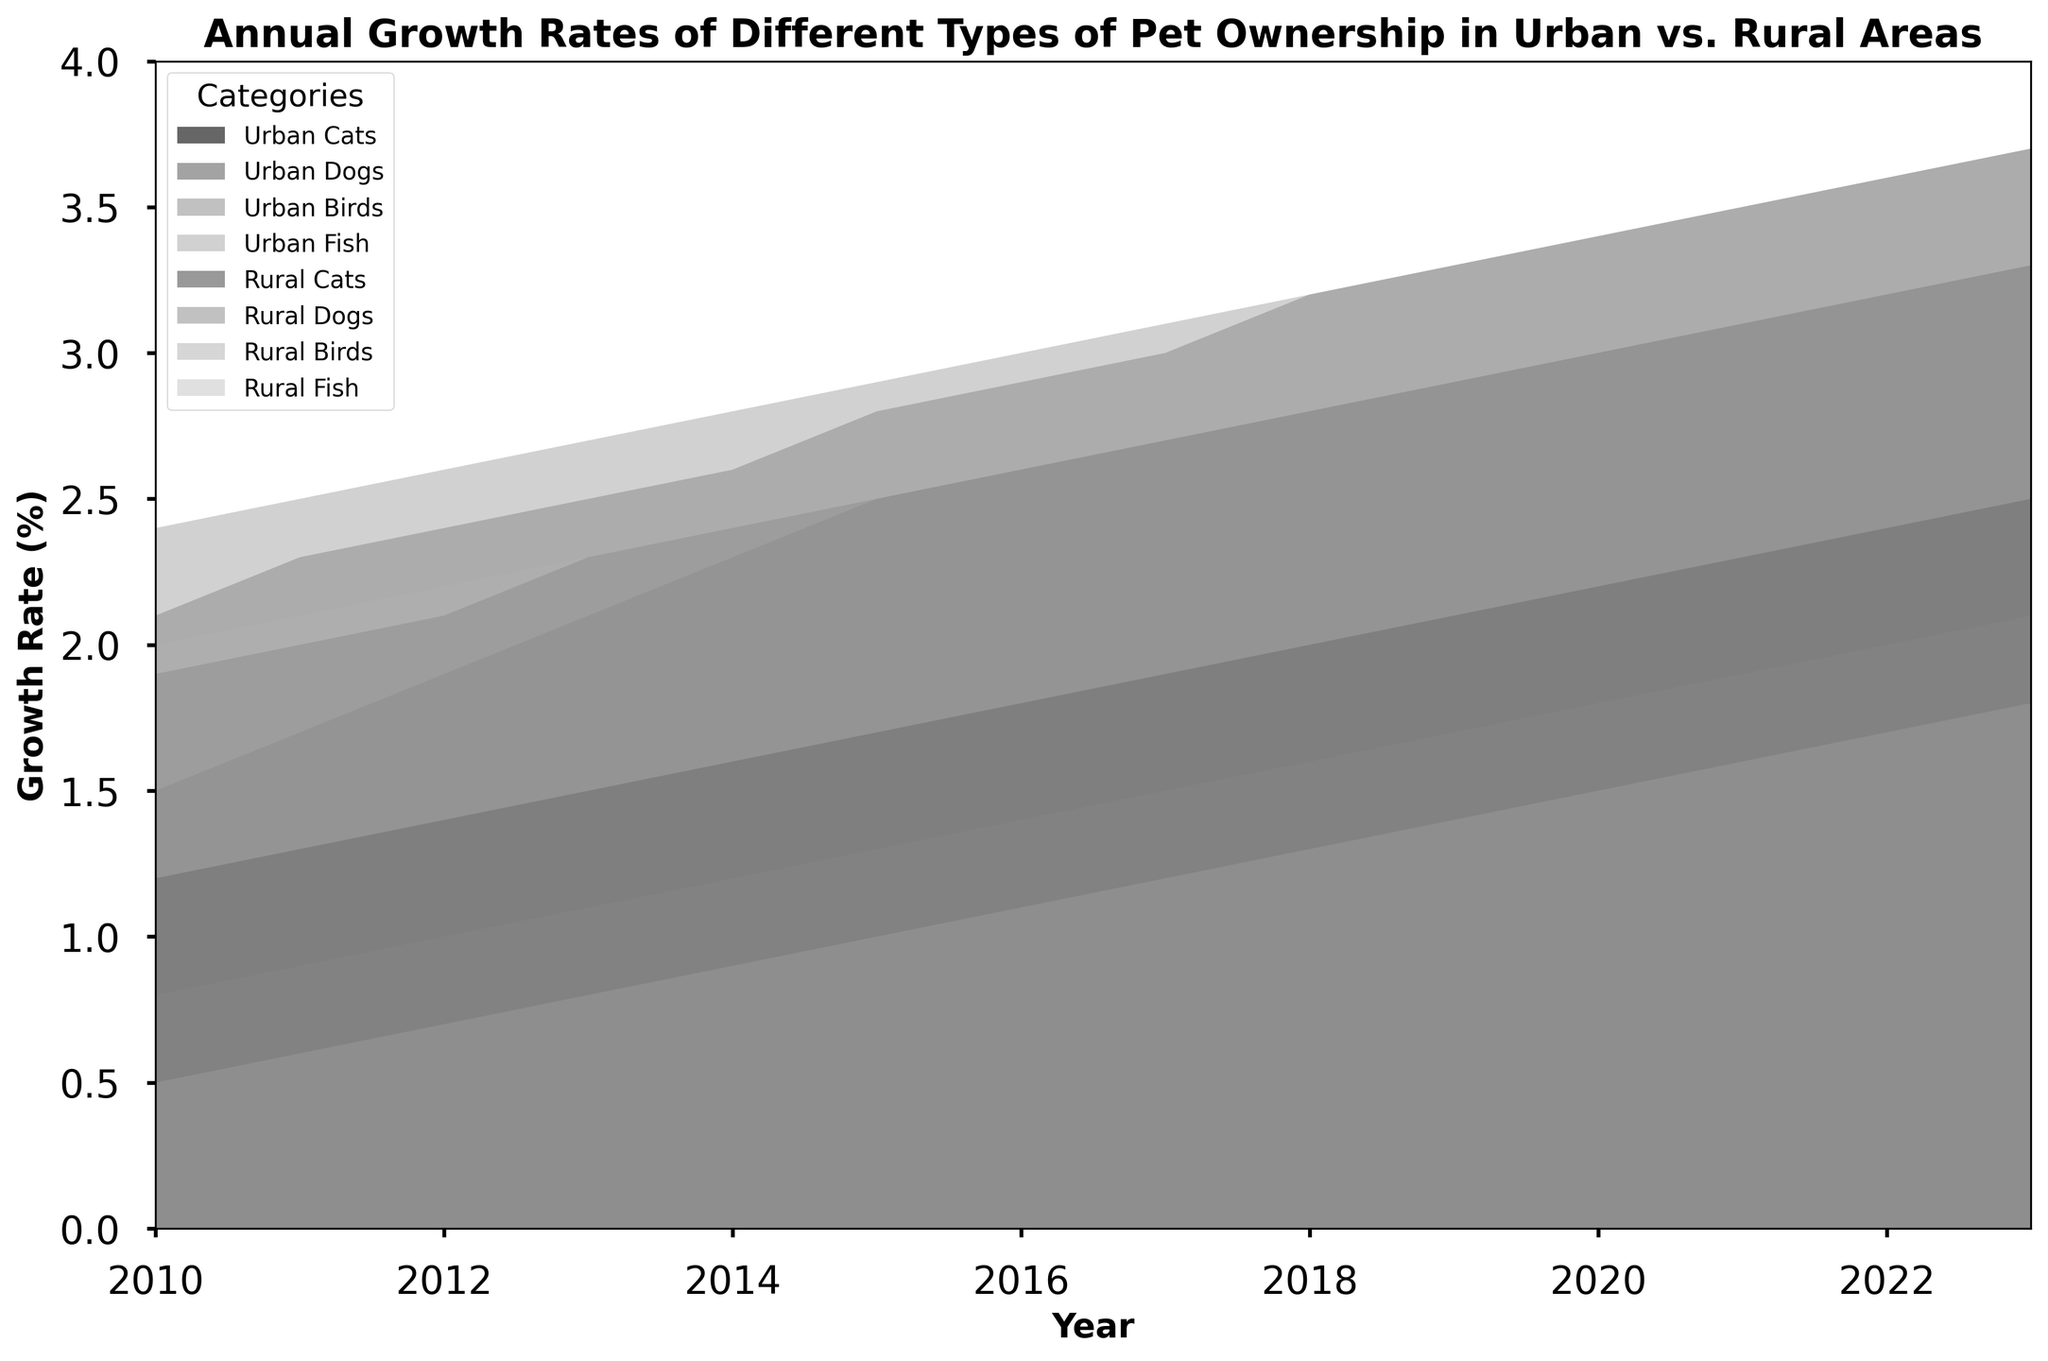How has the growth rate of urban dog ownership changed from 2010 to 2023? To find this, locate the values for Urban_Dogs in 2010 and 2023. The growth rate in 2010 is 2.1% and in 2023 is 3.7%. The difference is 3.7 - 2.1 = 1.6%.
Answer: 1.6% Which type of pet ownership has the lowest growth rate in rural areas in 2023, and what is the growth rate? Identify the smallest value among Rural_Cats, Rural_Dogs, Rural_Birds, and Rural_Fish in 2023. The values are 2.5%, 3.3%, 1.8%, and 3.3% respectively. Thus, Rural_Birds have the lowest growth rate of 1.8%.
Answer: Rural_Birds, 1.8% What is the sum of the growth rates of all urban pet ownership categories in the year 2017? Sum up the growth rates for Urban_Cats, Urban_Dogs, Urban_Birds, and Urban_Fish in 2017. These values are 2.7, 3.0, 1.5, and 3.1. The total is 2.7 + 3.0 + 1.5 + 3.1 = 10.3%.
Answer: 10.3% How does the growth rate of rural cat ownership in 2020 compare to the growth rate of urban cat ownership in the same year? Locate the values for Rural_Cats and Urban_Cats in 2020. Rural_Cats is 2.2% and Urban_Cats is 3.0%. Urban cat ownership is 3.0 - 2.2 = 0.8% higher.
Answer: Urban cats growth rate is 0.8% higher Which type of pet ownership shows the steadiest growth trend in urban areas from 2010 to 2023? Look for the most consistent and smooth curve among Urban_Cats, Urban_Dogs, Urban_Birds, and Urban_Fish. Urban_Fish shows a steady increase with minimal fluctuations.
Answer: Urban_Fish In which year did urban bird ownership first surpass the 1% growth rate? Trace the Urban_Birds line and identify the first year where it exceeds 1%. This occurs in 2012 when the rate is 1.0%.
Answer: 2012 What is the difference in the growth rates of urban dog ownership and rural dog ownership in 2023? Find the values for Urban_Dogs and Rural_Dogs in 2023. Urban_Dogs is 3.7% and Rural_Dogs is 3.3%. The difference is 3.7 - 3.3 = 0.4%.
Answer: 0.4% Which category has the highest growth rate in rural areas for the year 2015? Compare the values for Rural_Cats, Rural_Dogs, Rural_Birds, and Rural_Fish in 2015. The values are 1.7%, 2.5%, 1.0%, and 2.5%. Both Rural_Dogs and Rural_Fish have the highest rate at 2.5%.
Answer: Rural_Dogs and Rural_Fish What average growth rate do urban fish and rural fish ownership show over the period from 2010 to 2023? Calculate the average growth rate for Urban_Fish and Rural_Fish by summing the respective rates for each year and dividing by the number of years (14). Urban_Fish: (2.4+2.5+2.6+2.7+2.8+2.9+3.0+3.1+3.2+3.3+3.4+3.5+3.6+3.7) / 14 = 3.00%. Rural_Fish: (2.0+2.1+2.2+2.3+2.4+2.5+2.6+2.7+2.8+2.9+3.0+3.1+3.2+3.3) / 14 = 2.67%.
Answer: Urban_Fish: 3.00%, Rural_Fish: 2.67% 